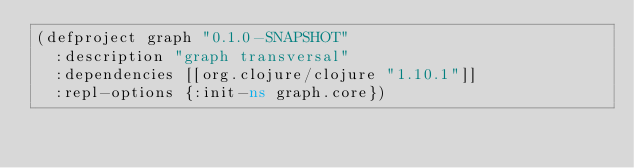Convert code to text. <code><loc_0><loc_0><loc_500><loc_500><_Clojure_>(defproject graph "0.1.0-SNAPSHOT"
  :description "graph transversal"
  :dependencies [[org.clojure/clojure "1.10.1"]]
  :repl-options {:init-ns graph.core})
</code> 